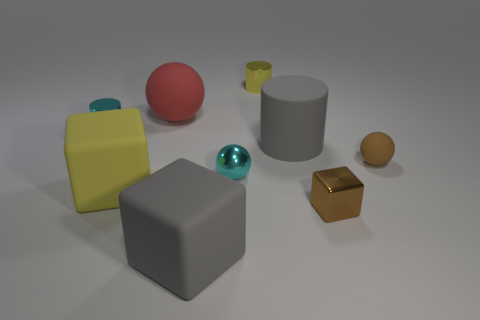What is the shape of the yellow object that is the same size as the cyan metal ball?
Offer a terse response. Cylinder. What is the color of the rubber block to the right of the big yellow object?
Make the answer very short. Gray. What number of objects are either rubber cubes in front of the large yellow rubber thing or small shiny cylinders on the left side of the tiny yellow shiny cylinder?
Your answer should be compact. 2. Is the size of the gray rubber cylinder the same as the red sphere?
Offer a very short reply. Yes. What number of spheres are either large things or large red matte objects?
Provide a succinct answer. 1. How many tiny brown things are behind the brown metal cube and in front of the tiny metallic ball?
Keep it short and to the point. 0. There is a yellow metal thing; is its size the same as the rubber thing that is right of the gray rubber cylinder?
Your answer should be compact. Yes. There is a big block to the left of the gray object that is in front of the gray cylinder; is there a small cyan cylinder that is on the right side of it?
Give a very brief answer. No. What material is the big thing that is right of the tiny sphere to the left of the small brown rubber object?
Provide a short and direct response. Rubber. There is a cylinder that is both behind the gray rubber cylinder and right of the red object; what is its material?
Ensure brevity in your answer.  Metal. 